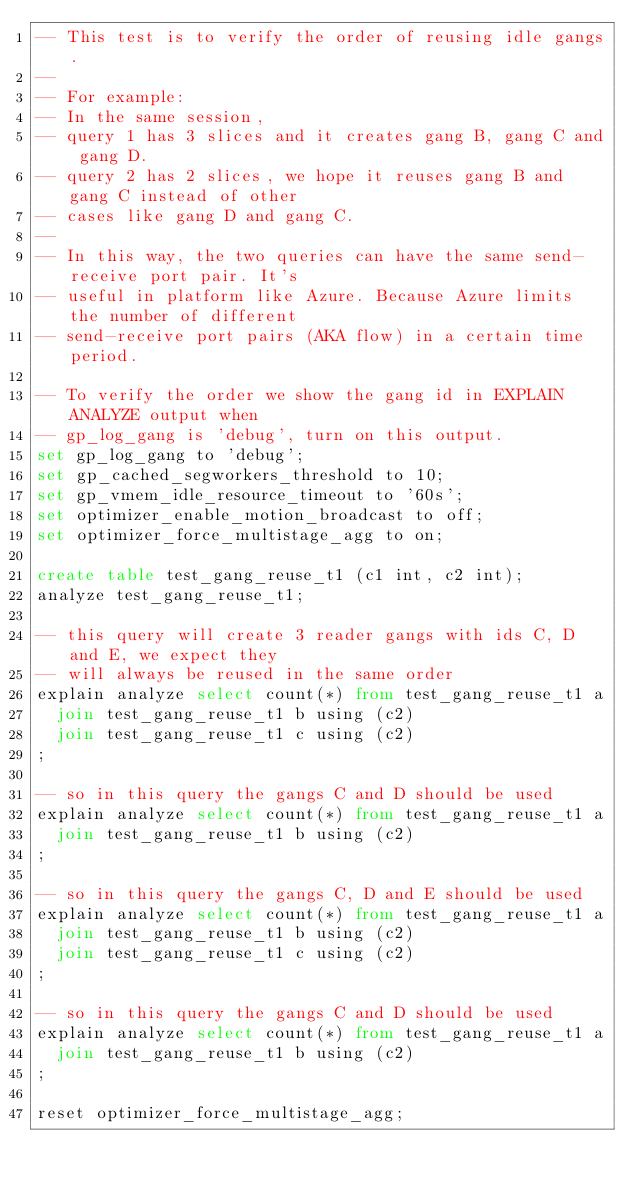Convert code to text. <code><loc_0><loc_0><loc_500><loc_500><_SQL_>-- This test is to verify the order of reusing idle gangs.
--
-- For example:
-- In the same session,
-- query 1 has 3 slices and it creates gang B, gang C and gang D.
-- query 2 has 2 slices, we hope it reuses gang B and gang C instead of other
-- cases like gang D and gang C.
--
-- In this way, the two queries can have the same send-receive port pair. It's
-- useful in platform like Azure. Because Azure limits the number of different
-- send-receive port pairs (AKA flow) in a certain time period.

-- To verify the order we show the gang id in EXPLAIN ANALYZE output when
-- gp_log_gang is 'debug', turn on this output.
set gp_log_gang to 'debug';
set gp_cached_segworkers_threshold to 10;
set gp_vmem_idle_resource_timeout to '60s';
set optimizer_enable_motion_broadcast to off;
set optimizer_force_multistage_agg to on;

create table test_gang_reuse_t1 (c1 int, c2 int);
analyze test_gang_reuse_t1;

-- this query will create 3 reader gangs with ids C, D and E, we expect they
-- will always be reused in the same order
explain analyze select count(*) from test_gang_reuse_t1 a
  join test_gang_reuse_t1 b using (c2)
  join test_gang_reuse_t1 c using (c2)
;

-- so in this query the gangs C and D should be used
explain analyze select count(*) from test_gang_reuse_t1 a
  join test_gang_reuse_t1 b using (c2)
;

-- so in this query the gangs C, D and E should be used
explain analyze select count(*) from test_gang_reuse_t1 a
  join test_gang_reuse_t1 b using (c2)
  join test_gang_reuse_t1 c using (c2)
;

-- so in this query the gangs C and D should be used
explain analyze select count(*) from test_gang_reuse_t1 a
  join test_gang_reuse_t1 b using (c2)
;

reset optimizer_force_multistage_agg;
</code> 